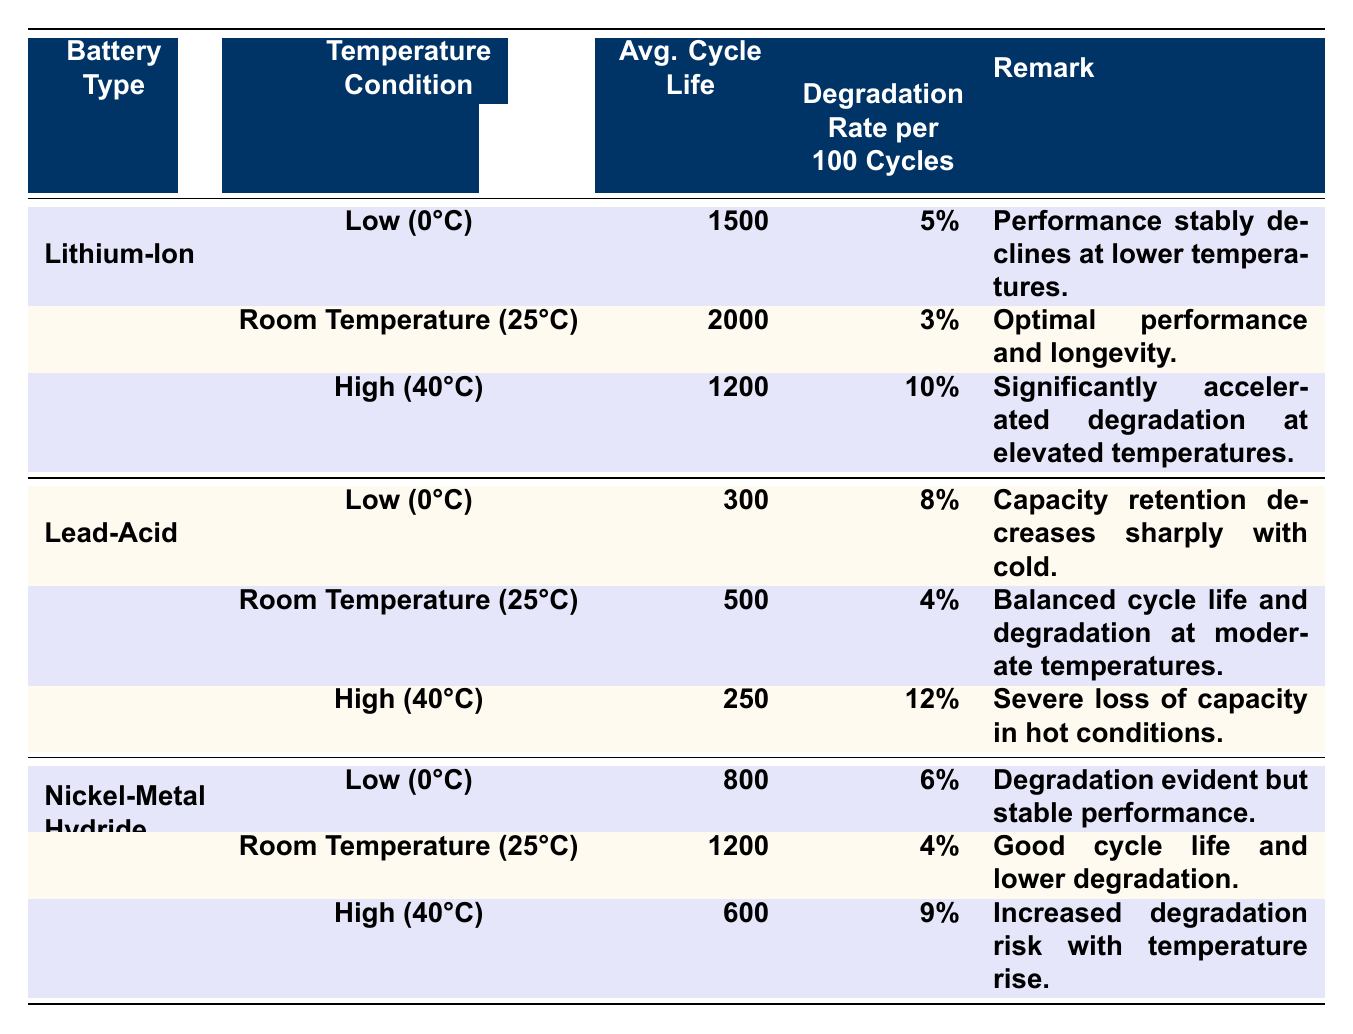What is the average cycle life of the Lithium-Ion battery at room temperature? The table shows that the average cycle life of the Lithium-Ion battery at room temperature (25°C) is 2000 cycles.
Answer: 2000 Which battery type has the lowest average cycle life at high temperature? In the high-temperature section (40°C), the Lead-Acid battery has the lowest average cycle life of 250 cycles compared to the Lithium-Ion (1200 cycles) and Nickel-Metal Hydride (600 cycles) batteries.
Answer: Lead-Acid battery What is the degradation rate of the Nickel-Metal Hydride battery at low temperature? From the table, the degradation rate per 100 cycles for the Nickel-Metal Hydride battery at low temperature (0°C) is 6%.
Answer: 6% Which battery type experiences a sharper decline in performance in cold conditions, Lithium-Ion or Lead-Acid? Looking at the low-temperature performance, the Lithium-Ion battery has an average cycle life of 1500, while the Lead-Acid battery only has 300 cycles. Thus, the Lead-Acid battery experiences a sharper decline.
Answer: Lead-Acid battery How does the average cycle life of the Lithium-Ion battery at high temperature compare to that at low temperature? The average cycle life of the Lithium-Ion battery at high temperature (1200 cycles) is less than at low temperature (1500 cycles). The difference is 300 cycles.
Answer: 300 cycles less What is the total average cycle life of all battery types at room temperature? Summing the average cycle life values at room temperature gives 2000 (Lithium-Ion) + 500 (Lead-Acid) + 1200 (Nickel-Metal Hydride) = 3700 cycles.
Answer: 3700 cycles Does any battery type show an average cycle life greater than 2000 cycles across all temperature conditions? The only battery type with an average cycle life greater than 2000 cycles is the Lithium-Ion battery, which has 2000 cycles at room temperature.
Answer: Yes Which temperature condition leads to the highest degradation rate for Lead-Acid batteries? The highest degradation rate for Lead-Acid batteries is at high temperature (40°C), where it is 12% per 100 cycles, compared to 8% at low (0°C) and 4% at room temperature (25°C).
Answer: High temperature (40°C) What is the trend in average cycle life with respect to temperature for Nickel-Metal Hydride batteries? For Nickel-Metal Hydride batteries, the average cycle life decreases as the temperature increases: 800 cycles at low (0°C), 1200 cycles at room temperature (25°C), and down to 600 cycles at high (40°C).
Answer: Decreasing trend Which temperature condition results in optimal performance for Lithium-Ion batteries according to the table? The table indicates that room temperature (25°C) results in optimal performance for Lithium-Ion batteries, with an average cycle life of 2000 cycles and the lowest degradation rate of 3%.
Answer: Room temperature (25°C) 